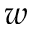<formula> <loc_0><loc_0><loc_500><loc_500>w</formula> 